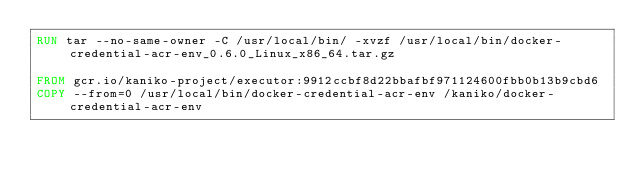Convert code to text. <code><loc_0><loc_0><loc_500><loc_500><_Dockerfile_>RUN tar --no-same-owner -C /usr/local/bin/ -xvzf /usr/local/bin/docker-credential-acr-env_0.6.0_Linux_x86_64.tar.gz

FROM gcr.io/kaniko-project/executor:9912ccbf8d22bbafbf971124600fbb0b13b9cbd6
COPY --from=0 /usr/local/bin/docker-credential-acr-env /kaniko/docker-credential-acr-env
</code> 